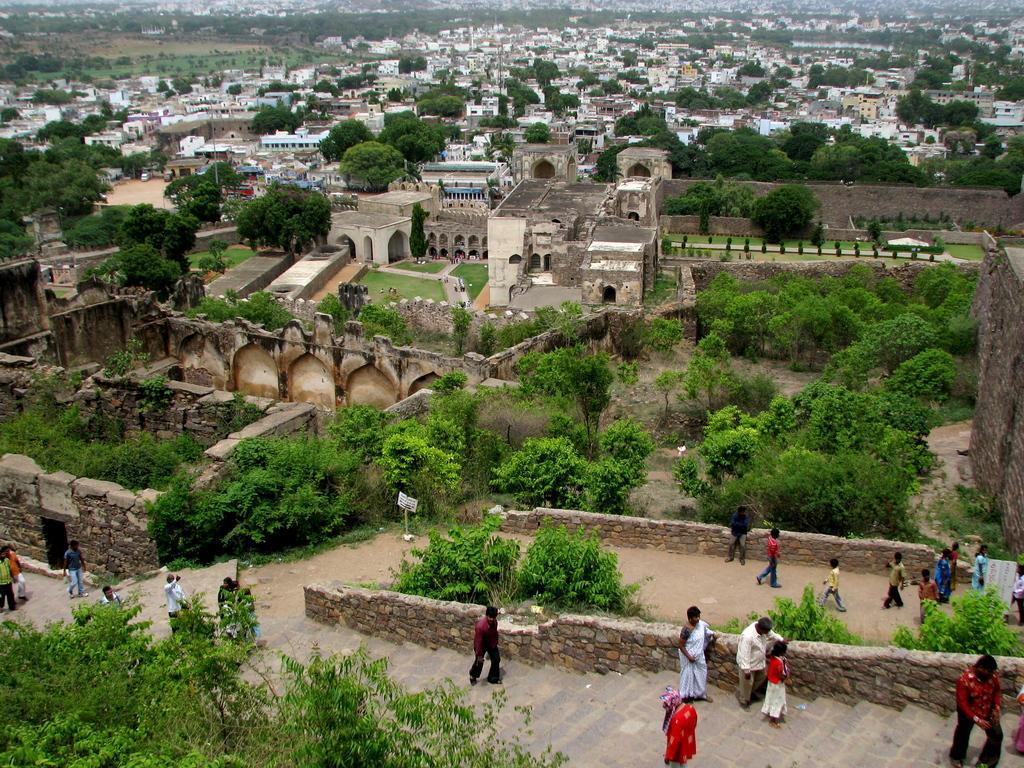Could you give a brief overview of what you see in this image? In this image, I can see the view of the city. These are the houses and buildings. There are groups of people walking. These are the stairs. I think this is a fort. These are the trees with branches and leaves. 